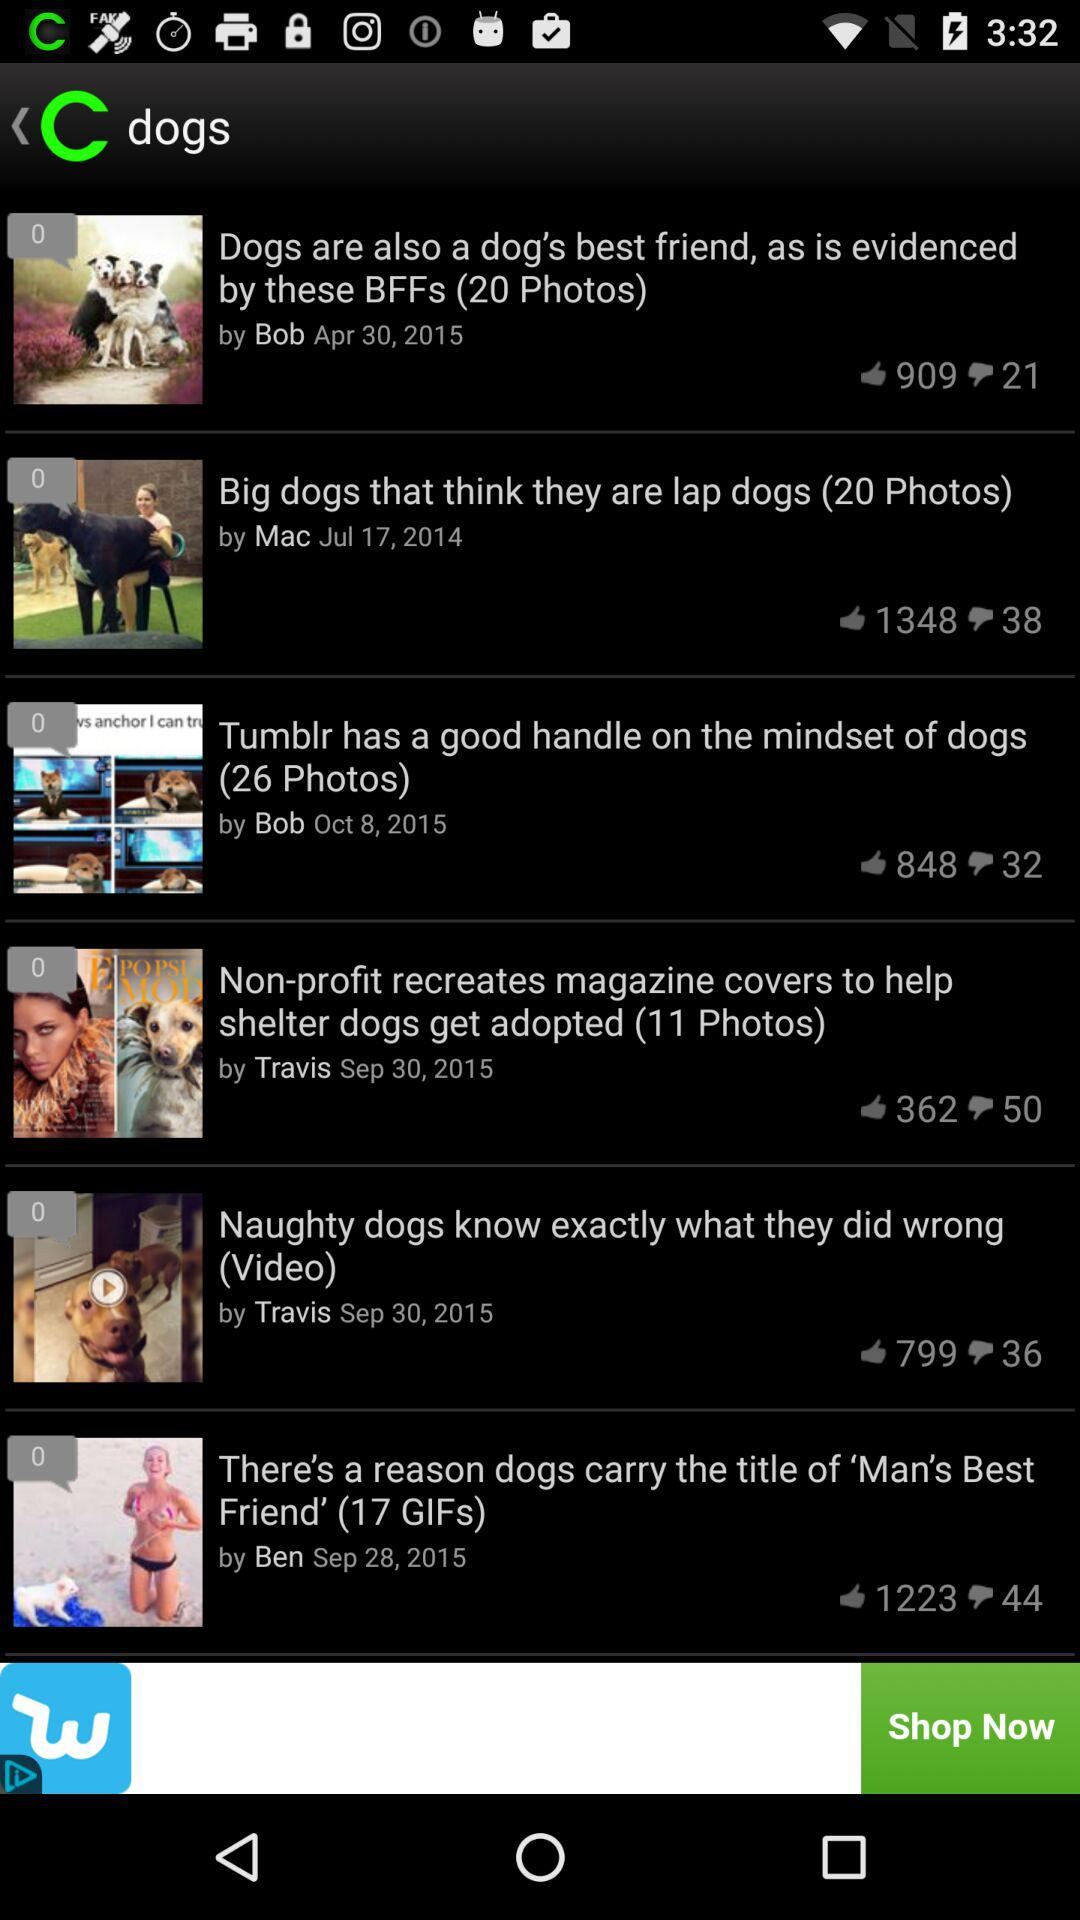On which date the post Big dogs is updated?
When the provided information is insufficient, respond with <no answer>. <no answer> 